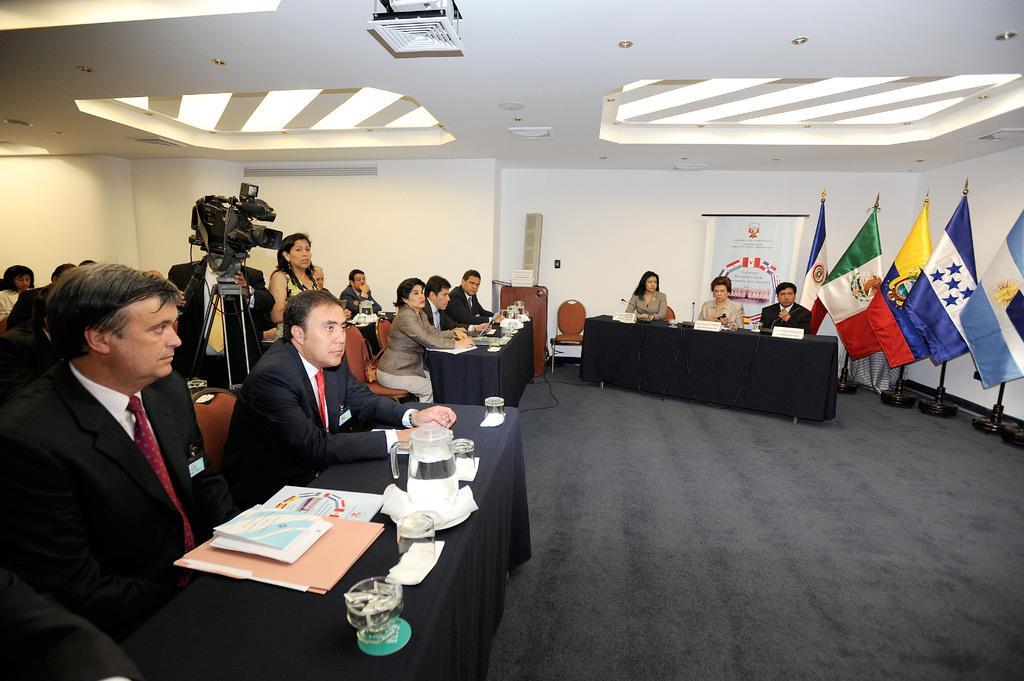Can you describe this image briefly? In this image on the left side there are some people who are sitting and in front of them there are some tables. On the table we could see some books, glasses and some tissue papers. And on the right side there is one table and three persons are sitting on chairs and also there are some flags and poles. In the center there are some boards and one chair, on the top there is ceiling and some lights. 